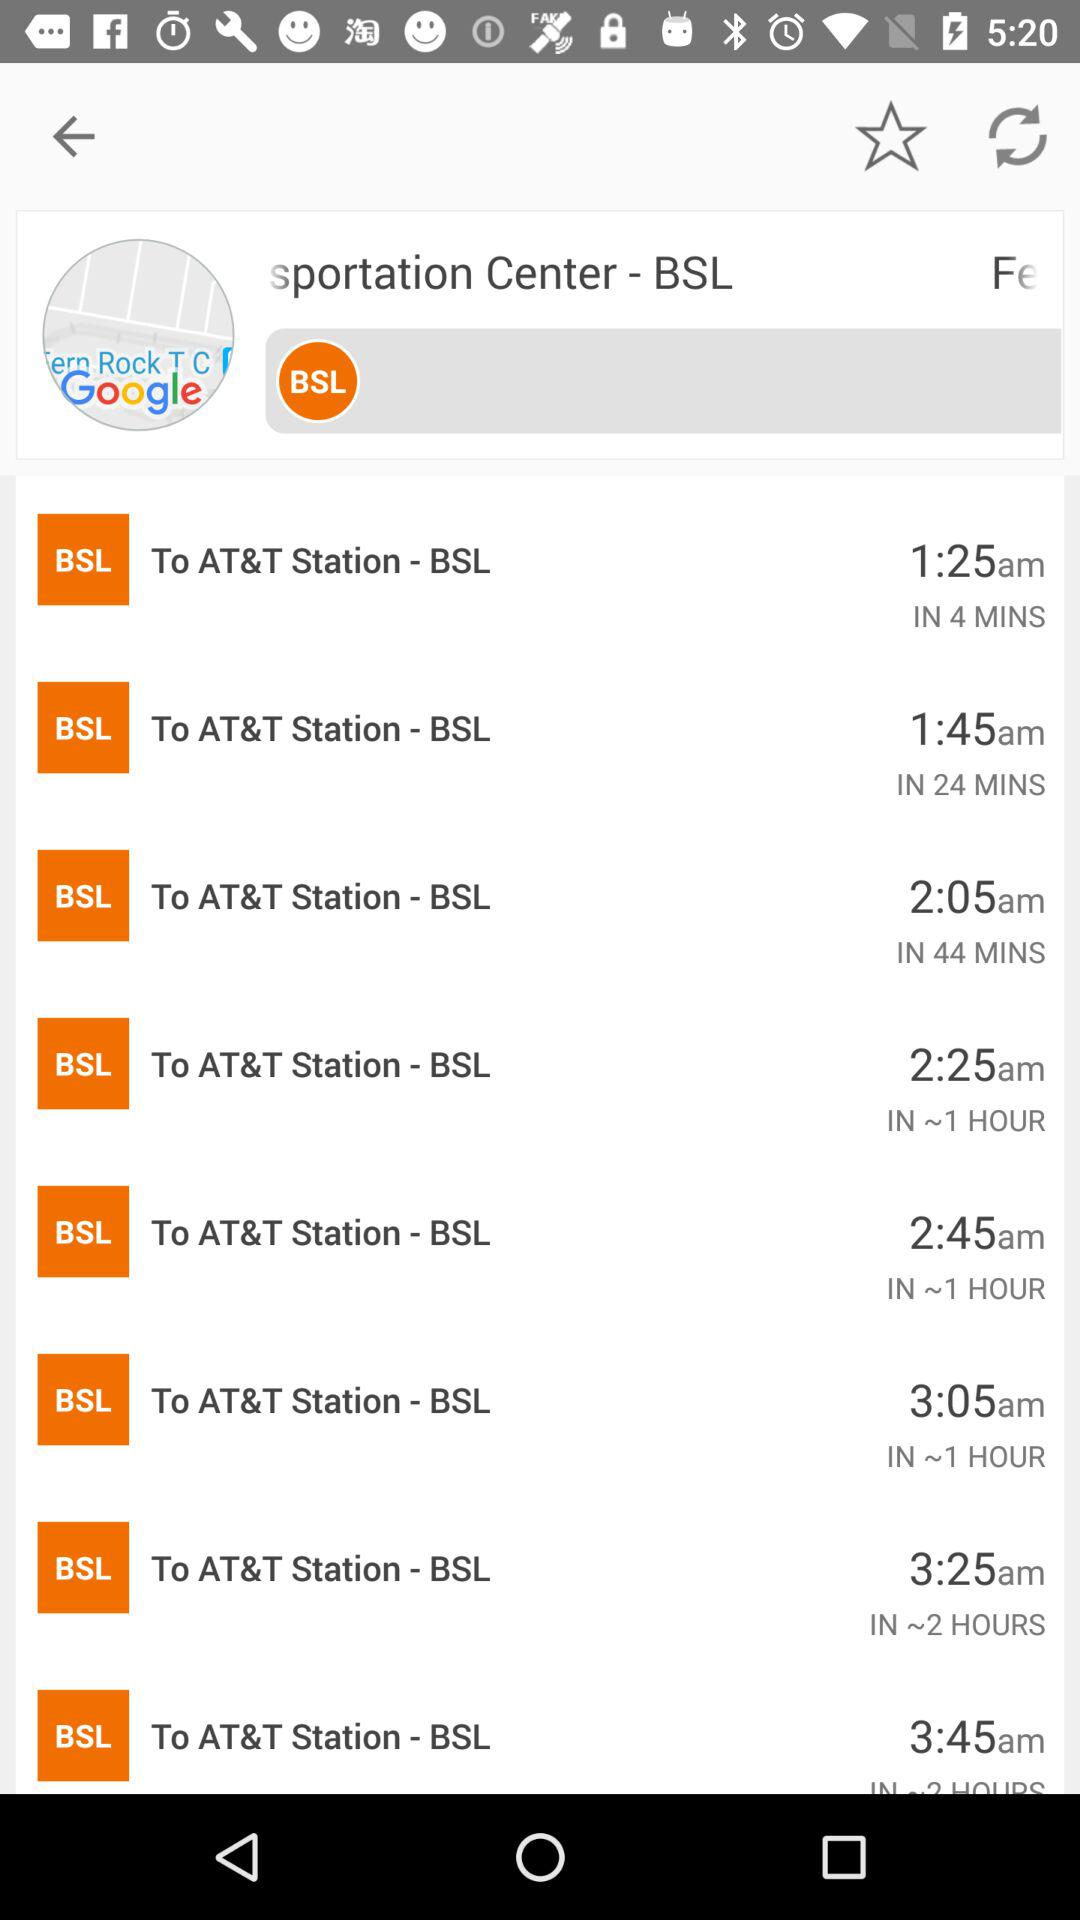How many minutes are there between the first and last bus times?
Answer the question using a single word or phrase. 120 